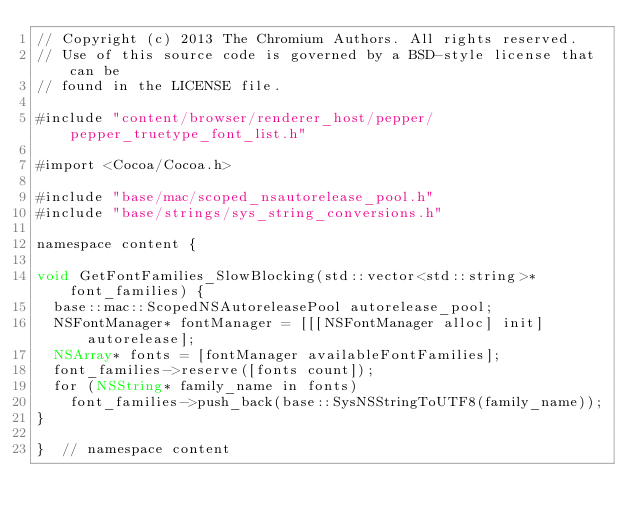Convert code to text. <code><loc_0><loc_0><loc_500><loc_500><_ObjectiveC_>// Copyright (c) 2013 The Chromium Authors. All rights reserved.
// Use of this source code is governed by a BSD-style license that can be
// found in the LICENSE file.

#include "content/browser/renderer_host/pepper/pepper_truetype_font_list.h"

#import <Cocoa/Cocoa.h>

#include "base/mac/scoped_nsautorelease_pool.h"
#include "base/strings/sys_string_conversions.h"

namespace content {

void GetFontFamilies_SlowBlocking(std::vector<std::string>* font_families) {
  base::mac::ScopedNSAutoreleasePool autorelease_pool;
  NSFontManager* fontManager = [[[NSFontManager alloc] init] autorelease];
  NSArray* fonts = [fontManager availableFontFamilies];
  font_families->reserve([fonts count]);
  for (NSString* family_name in fonts)
    font_families->push_back(base::SysNSStringToUTF8(family_name));
}

}  // namespace content
</code> 